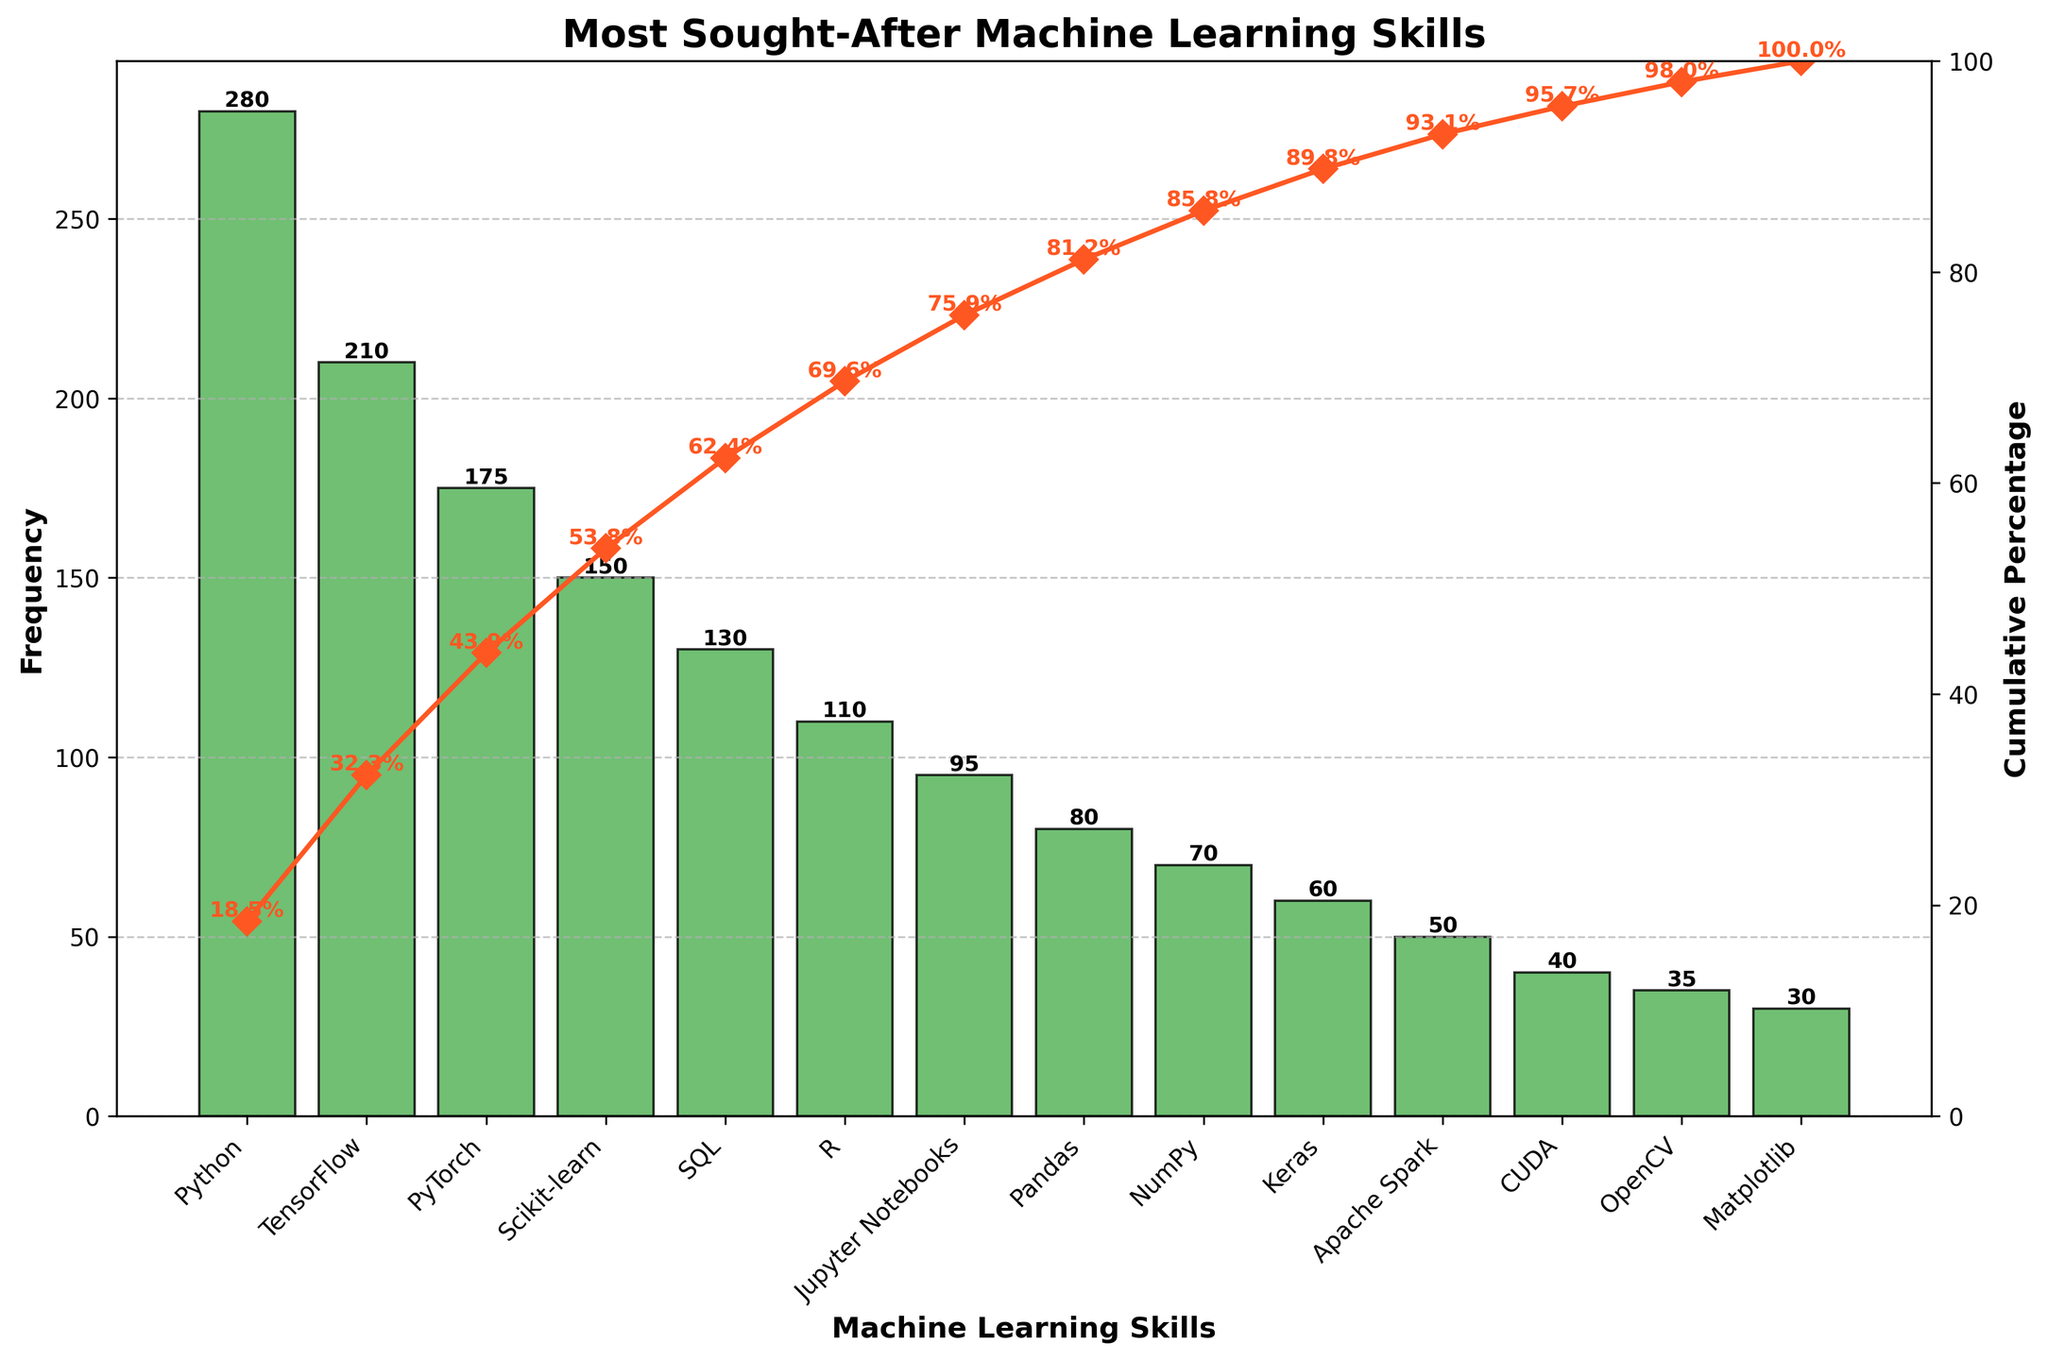What is the most sought-after machine learning skill according to the figure? Look for the highest bar in the bar chart, which represents the skill with the highest frequency of demand. The label under this bar indicates the skill.
Answer: Python How many skills are shown in the figure? Count the number of bars in the bar chart to determine the total number of skills represented.
Answer: 14 What is the cumulative percentage for TensorFlow? Locate the bar for TensorFlow and find the corresponding cumulative percentage on the secondary y-axis or the label near the curve.
Answer: 66.3% Which skill has the lowest frequency, and what is its value? Identify the bar with the smallest height and note the skill label and its frequency value.
Answer: Matplotlib, 30 What is the total frequency of the top three skills? Sum the frequencies of Python (280), TensorFlow (210), and PyTorch (175). Add these values together.
Answer: 665 Which skills account for at least 90% of the cumulative percentage? Observe the cumulative percentage plotted line and identify skills up to the point where the percentage reaches at least 90%. This is around Apache Spark.
Answer: Python, TensorFlow, PyTorch, Scikit-learn, SQL, R, Jupyter Notebooks, Pandas, NumPy, Keras, Apache Spark How does the frequency of PyTorch compare to Scikit-learn? Compare the frequencies directly by checking the height of the bars or the value labels for PyTorch and Scikit-learn.
Answer: PyTorch (175) is greater than Scikit-learn (150) What is the frequency difference between the skills ranked second and fourth? Identify the frequencies for TensorFlow (second, 210) and Scikit-learn (fourth, 150) and subtract to find the difference.
Answer: 60 What percentage of the total frequency does the top skill contribute? The cumulative frequency for Python (280) divided by the total frequency sum (1615), multiplied by 100 to get the percentage.
Answer: 17.3% How many skills have a frequency higher than 100? Count the number of bars with a value above the 100 frequency mark. These are Python, TensorFlow, PyTorch, Scikit-learn, SQL, and R.
Answer: 6 